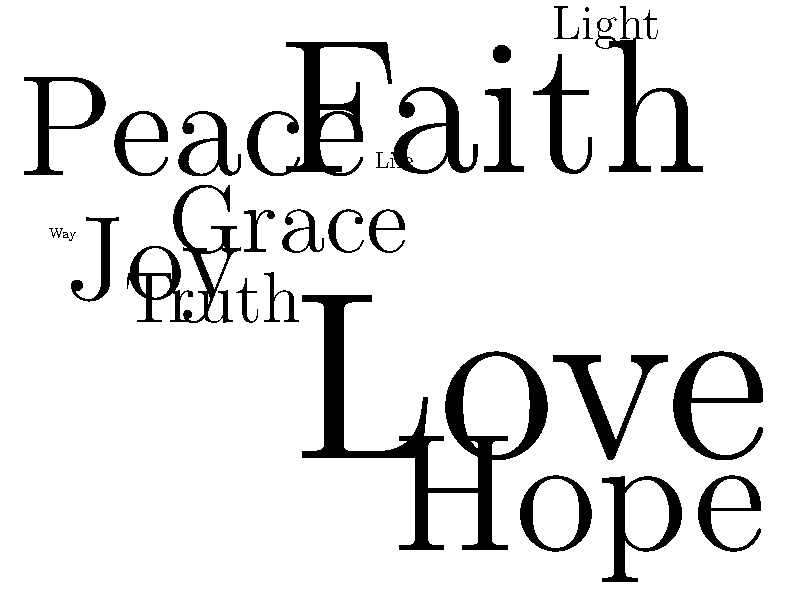Based on the word cloud representing popular Bible verses, which word appears to be the most frequently used, suggesting it might be from a well-known verse? To determine the most frequently used word in this word cloud:

1. Observe that the size of each word represents its frequency or importance.
2. Compare the relative sizes of all words in the cloud.
3. Identify the largest word, which indicates the highest frequency.
4. In this word cloud, "Love" appears to be the largest word.
5. This suggests that "Love" is the most frequently used word among these popular Bible verses.
6. It likely refers to verses such as 1 Corinthians 13:13 or John 3:16, which emphasize love as a central theme in Christian teachings.
Answer: Love 